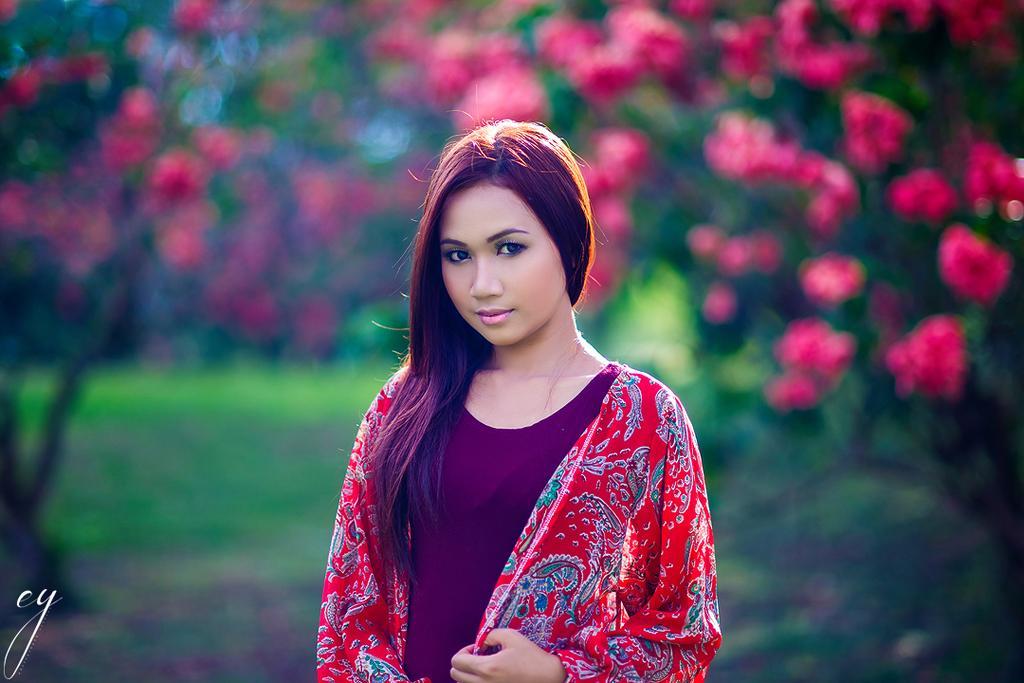Can you describe this image briefly? In the foreground of this image, there is a woman standing. In the background, there are flowers and the greenery. 